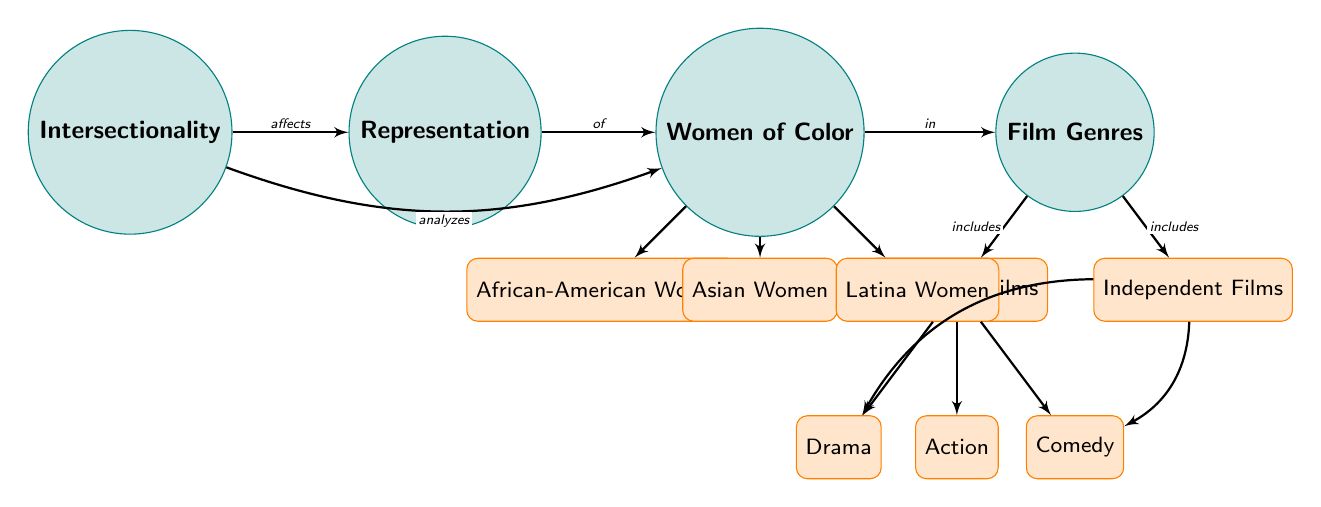What is the main focus of the diagram? The main node labeled "Intersectionality" indicates that the diagram primarily focuses on the concept of intersectionality as it relates to representation in film, particularly concerning women of color.
Answer: Intersectionality How many major categories are under "Women of Color"? There are three sub-nodes under "Women of Color": African-American Women, Asian Women, and Latina Women. Therefore, the count is three.
Answer: 3 Which film genre is connected to both Hollywood and Independent Films? The sub-node "Drama" is connected to both the Hollywood and Independent Films categories, indicating its presence in both genres.
Answer: Drama What relationship does "Intersectionality" have with "Representation"? The diagram shows a direct edge labeled "affects," indicating that intersectionality affects representation.
Answer: Affects Which type of films does the diagram specify under the "Film Genres" category? The diagram specifies that "Hollywood Films" and "Independent Films" are the two main types listed under the "Film Genres" category.
Answer: Hollywood Films, Independent Films What is the relationship between "Women of Color" and "Film Genres"? The edge directed from "Women of Color" to "Film Genres" indicates that the representation of women of color occurs within the various film genres listed.
Answer: In Which color represents main nodes in the diagram? The main nodes are represented in a teal color, as indicated by the styles defined in the diagram's code.
Answer: Teal How many types of films are specified under the "Hollywood Films" category? There are three sub-nodes under the "Hollywood Films" category: Drama, Action, and Comedy, which totals three types.
Answer: 3 Which sub-node connects to "Asian Women"? The direct edge shows that "Asian Women" is a sub-node of "Women of Color," indicating it belongs to this category.
Answer: Women of Color What does the edge labeled "analyzes" illustrate between "Intersectionality" and "Women of Color"? The edge labeled "analyzes" connects "Intersectionality" to "Women of Color," illustrating that the analysis of intersectionality includes considerations of women of color in its scope.
Answer: Analyzes 